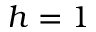Convert formula to latex. <formula><loc_0><loc_0><loc_500><loc_500>h = 1</formula> 